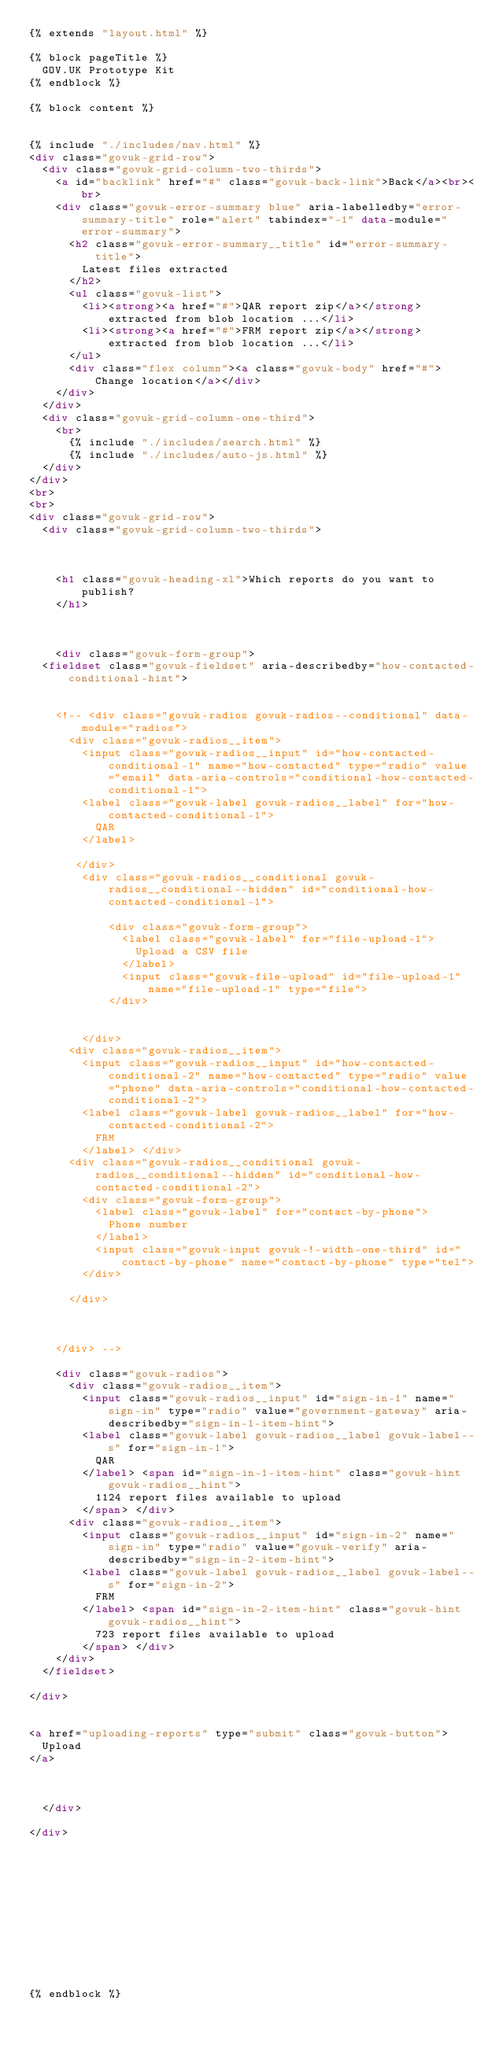<code> <loc_0><loc_0><loc_500><loc_500><_HTML_>{% extends "layout.html" %}

{% block pageTitle %}
  GOV.UK Prototype Kit
{% endblock %}

{% block content %}


{% include "./includes/nav.html" %}
<div class="govuk-grid-row">
  <div class="govuk-grid-column-two-thirds">
    <a id="backlink" href="#" class="govuk-back-link">Back</a><br><br>
    <div class="govuk-error-summary blue" aria-labelledby="error-summary-title" role="alert" tabindex="-1" data-module="error-summary">
      <h2 class="govuk-error-summary__title" id="error-summary-title">
        Latest files extracted
      </h2>
      <ul class="govuk-list">
        <li><strong><a href="#">QAR report zip</a></strong> extracted from blob location ...</li>
        <li><strong><a href="#">FRM report zip</a></strong> extracted from blob location ...</li>
      </ul>
      <div class="flex column"><a class="govuk-body" href="#">Change location</a></div>
    </div>
  </div>
  <div class="govuk-grid-column-one-third">
    <br>
      {% include "./includes/search.html" %}
      {% include "./includes/auto-js.html" %}
  </div>
</div>
<br>
<br>
<div class="govuk-grid-row">
  <div class="govuk-grid-column-two-thirds">



    <h1 class="govuk-heading-xl">Which reports do you want to publish?
    </h1>



    <div class="govuk-form-group">
  <fieldset class="govuk-fieldset" aria-describedby="how-contacted-conditional-hint">


    <!-- <div class="govuk-radios govuk-radios--conditional" data-module="radios">
      <div class="govuk-radios__item">
        <input class="govuk-radios__input" id="how-contacted-conditional-1" name="how-contacted" type="radio" value="email" data-aria-controls="conditional-how-contacted-conditional-1">
        <label class="govuk-label govuk-radios__label" for="how-contacted-conditional-1">
          QAR
        </label>

       </div>
        <div class="govuk-radios__conditional govuk-radios__conditional--hidden" id="conditional-how-contacted-conditional-1">

            <div class="govuk-form-group">
              <label class="govuk-label" for="file-upload-1">
                Upload a CSV file
              </label>
              <input class="govuk-file-upload" id="file-upload-1" name="file-upload-1" type="file">
            </div>


        </div>
      <div class="govuk-radios__item">
        <input class="govuk-radios__input" id="how-contacted-conditional-2" name="how-contacted" type="radio" value="phone" data-aria-controls="conditional-how-contacted-conditional-2">
        <label class="govuk-label govuk-radios__label" for="how-contacted-conditional-2">
          FRM
        </label> </div>
      <div class="govuk-radios__conditional govuk-radios__conditional--hidden" id="conditional-how-contacted-conditional-2">
        <div class="govuk-form-group">
          <label class="govuk-label" for="contact-by-phone">
            Phone number
          </label>
          <input class="govuk-input govuk-!-width-one-third" id="contact-by-phone" name="contact-by-phone" type="tel">
        </div>

      </div>



    </div> -->

    <div class="govuk-radios">
      <div class="govuk-radios__item">
        <input class="govuk-radios__input" id="sign-in-1" name="sign-in" type="radio" value="government-gateway" aria-describedby="sign-in-1-item-hint">
        <label class="govuk-label govuk-radios__label govuk-label--s" for="sign-in-1">
          QAR
        </label> <span id="sign-in-1-item-hint" class="govuk-hint govuk-radios__hint">
          1124 report files available to upload
        </span> </div>
      <div class="govuk-radios__item">
        <input class="govuk-radios__input" id="sign-in-2" name="sign-in" type="radio" value="govuk-verify" aria-describedby="sign-in-2-item-hint">
        <label class="govuk-label govuk-radios__label govuk-label--s" for="sign-in-2">
          FRM
        </label> <span id="sign-in-2-item-hint" class="govuk-hint govuk-radios__hint">
          723 report files available to upload
        </span> </div>
    </div>
  </fieldset>

</div>


<a href="uploading-reports" type="submit" class="govuk-button">
  Upload
</a>



  </div>

</div>












{% endblock %}
</code> 